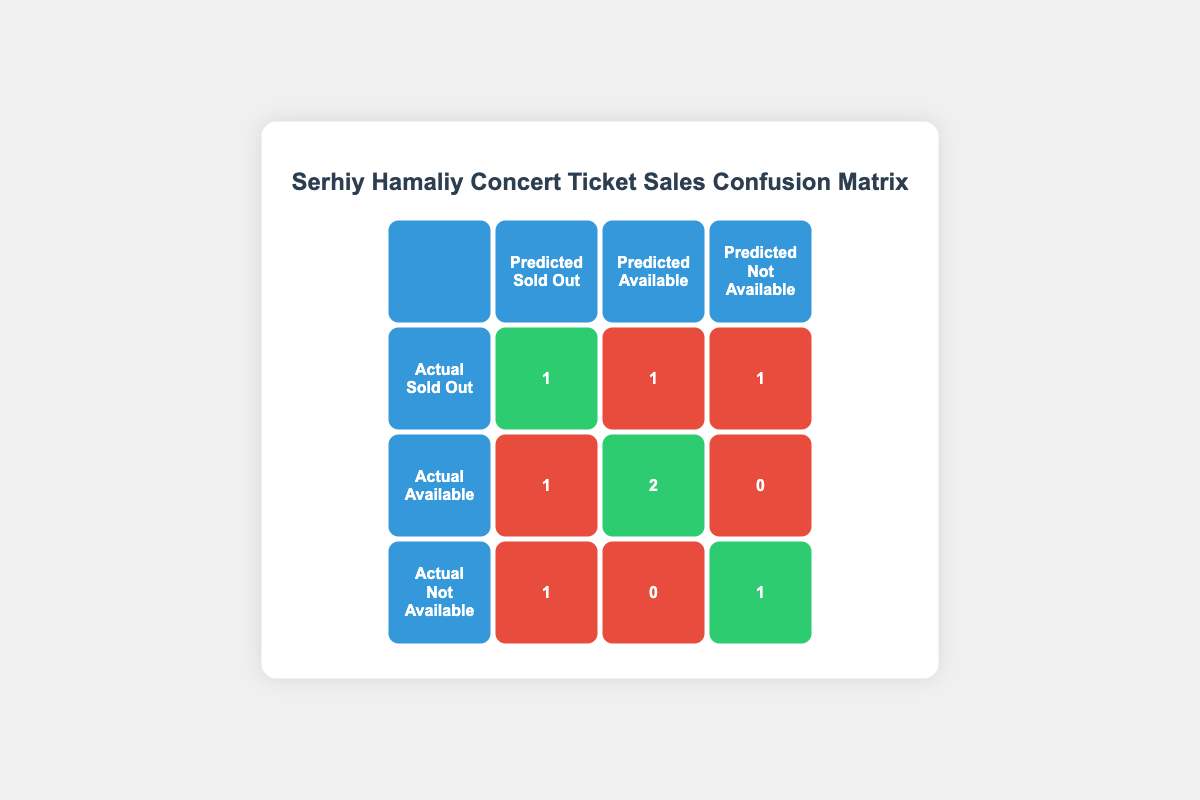What is the number of times tickets were correctly predicted as Sold Out? From the table, the cell corresponding to the actual Sold Out and predicted Sold Out shows the value 1. This means there was one correct prediction of tickets being Sold Out.
Answer: 1 How many times were tickets predicted to be Available? By looking at the cells under the "Predicted Available" column, we see two correct predictions (actual Available) and one incorrect prediction (actual Sold Out), making it a total of 3 times tickets were predicted to be Available.
Answer: 3 What is the total number of incorrect predictions? To find the total number of incorrect predictions, we add the incorrect predictions across all rows: 1 (Actual Sold Out, Predicted Available) + 1 (Actual Sold Out, Predicted Not Available) + 1 (Actual Available, Predicted Sold Out) + 1 (Actual Not Available, Predicted Sold Out) + 0 (Actual Available, Predicted Not Available) = 4 incorrect predictions in total.
Answer: 4 Did any tickets predicted as Sold Out actually come up as Not Available? Yes, there was one instance where the actual status was Not Available but it was predicted as Sold Out, as seen in the corresponding cell. This means there is at least one incorrect prediction of this type.
Answer: Yes How many times did the model fail to predict tickets that were Available? The model incorrectly predicted tickets that were Available once as Sold Out and zero times as Not Available. Thus, the total number of times the tickets that were actually Available were not correctly predicted is 1.
Answer: 1 Was the number of actually Sold Out tickets predicted as Available higher than those predicted as Not Available? From the table, there is 1 instance of the actual Sold Out being predicted as Available and 1 instance of actual Sold Out being predicted as Not Available. Since these numbers are equal, the answer is no, it was not higher.
Answer: No What is the combined total of tickets predicted as Not Available, regardless of actual availability? From the table, we see that predictions for Not Available show 1 (Actual Not Available, Predicted Not Available) and 1 (Actual Sold Out, Predicted Not Available). Combining these, we get a total of 2 tickets predicted as Not Available.
Answer: 2 What percentage of tickets were predicted correctly as Not Available? There is 1 correct prediction (actual Not Available predicted Not Available) out of 2 times it was either Not Available or Sold Out. To find the percentage, we calculate (1 correct / 2 total) * 100 = 50%.
Answer: 50% 